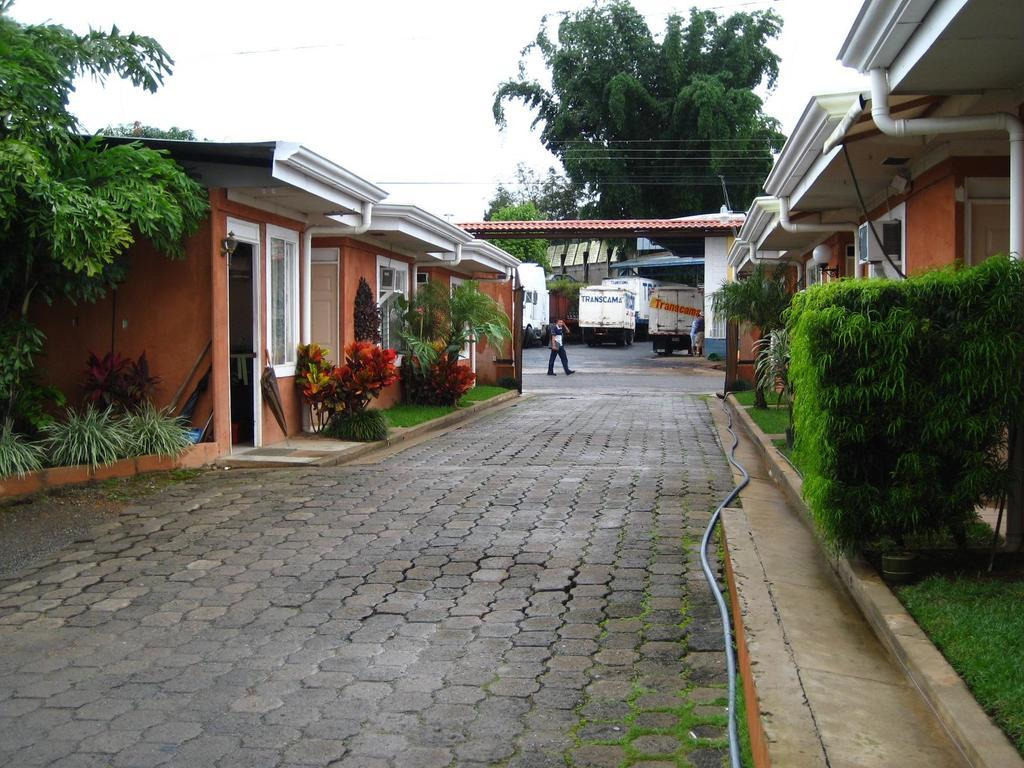What type of structures can be seen in the image? There are buildings in the image. What is located near the buildings? There are plants near the buildings. What other natural elements are present in the image? There are trees in the image. Can you describe the person in the image? There is a person walking on the road in the image. What is the location of the vehicles in the image? The vehicles are under a shed in the image. What can be seen in the background of the image? The sky is visible in the background of the image. What type of bread can be seen in the image? There is no bread present in the image. How many fingers does the person walking on the road have? The image does not show the person's fingers, so it cannot be determined from the image. 